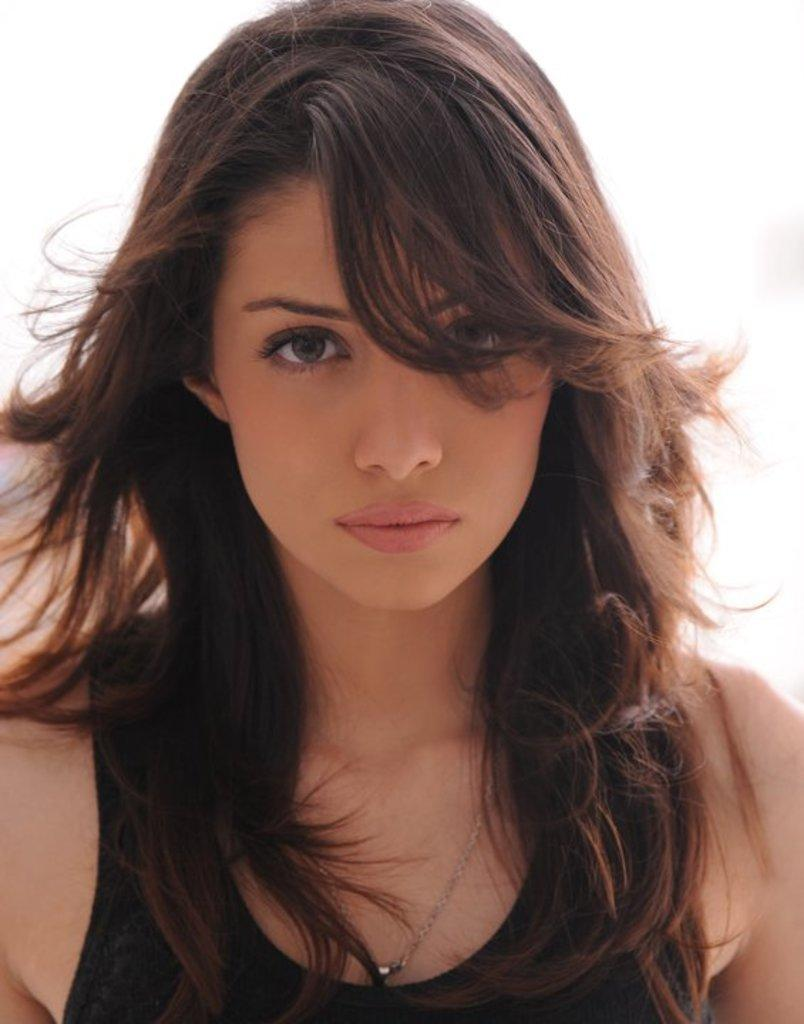Who is the main subject in the image? There is a lady in the image. What color is the background of the image? The background of the image is white. What type of tax is being discussed by the lady in the image? There is no indication in the image that the lady is discussing any type of tax. 